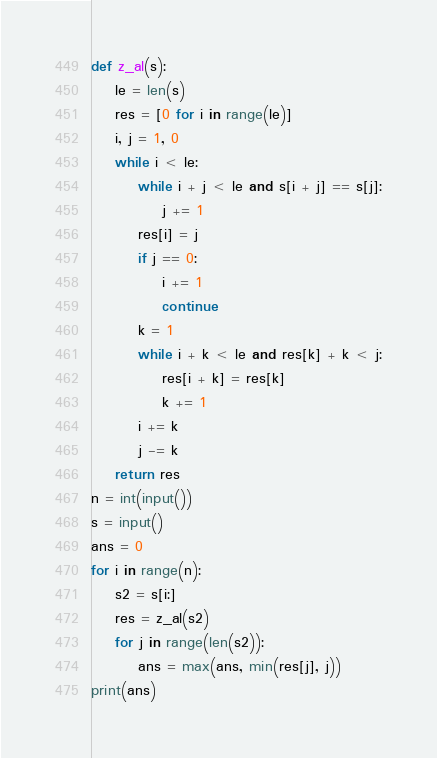<code> <loc_0><loc_0><loc_500><loc_500><_Python_>def z_al(s):
    le = len(s)
    res = [0 for i in range(le)]
    i, j = 1, 0
    while i < le:
        while i + j < le and s[i + j] == s[j]:
            j += 1
        res[i] = j
        if j == 0:
            i += 1
            continue
        k = 1
        while i + k < le and res[k] + k < j:
            res[i + k] = res[k]
            k += 1
        i += k
        j -= k
    return res
n = int(input())
s = input()
ans = 0
for i in range(n):
    s2 = s[i:]
    res = z_al(s2)
    for j in range(len(s2)):
        ans = max(ans, min(res[j], j))
print(ans)
</code> 